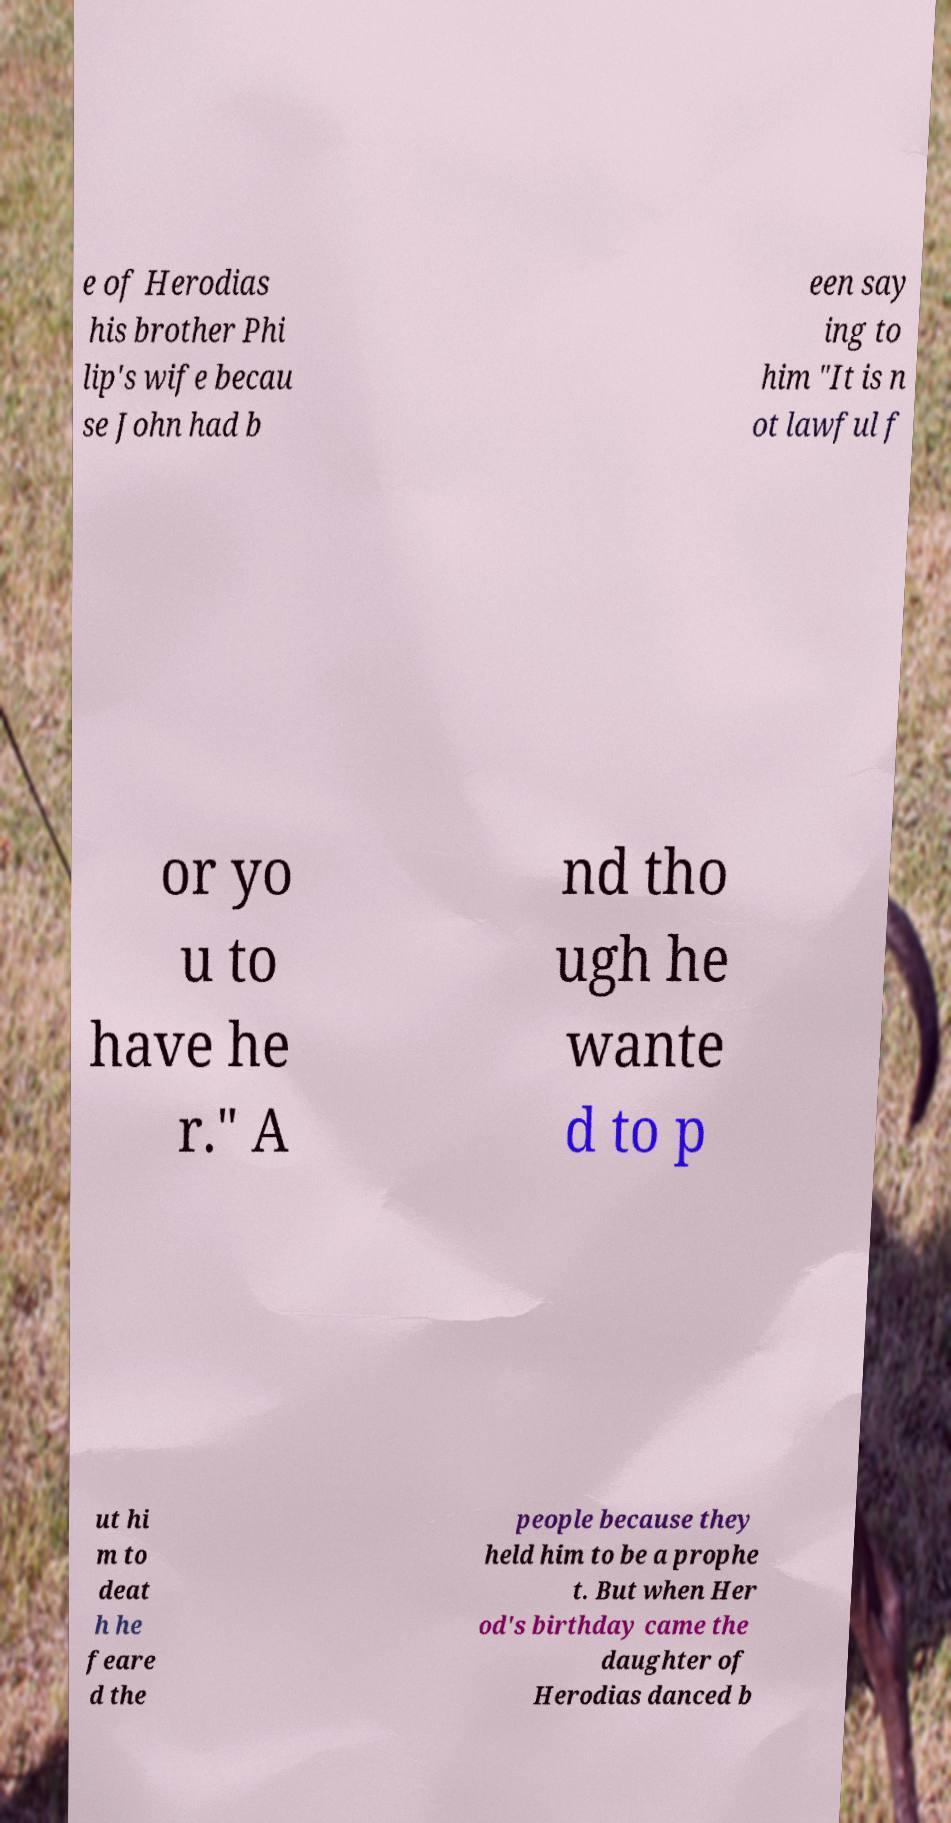There's text embedded in this image that I need extracted. Can you transcribe it verbatim? e of Herodias his brother Phi lip's wife becau se John had b een say ing to him "It is n ot lawful f or yo u to have he r." A nd tho ugh he wante d to p ut hi m to deat h he feare d the people because they held him to be a prophe t. But when Her od's birthday came the daughter of Herodias danced b 